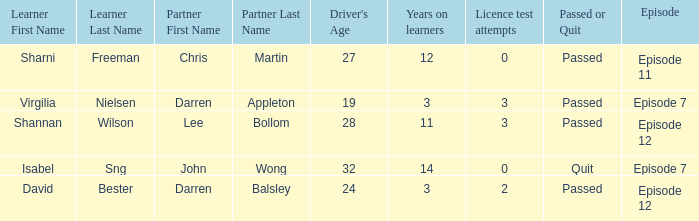Which driver is older than 24 and has more than 0 licence test attempts? Shannan Wilson. 